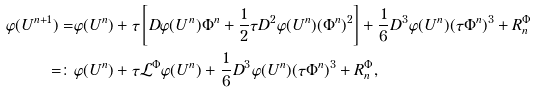Convert formula to latex. <formula><loc_0><loc_0><loc_500><loc_500>\varphi ( U ^ { n + 1 } ) = & \varphi ( U ^ { n } ) + \tau \left [ D \varphi ( U ^ { n } ) \Phi ^ { n } + \frac { 1 } { 2 } \tau D ^ { 2 } \varphi ( U ^ { n } ) ( \Phi ^ { n } ) ^ { 2 } \right ] + \frac { 1 } { 6 } D ^ { 3 } \varphi ( U ^ { n } ) ( \tau \Phi ^ { n } ) ^ { 3 } + R ^ { \Phi } _ { n } \\ = \colon & \varphi ( U ^ { n } ) + \tau \mathcal { L } ^ { \Phi } \varphi ( U ^ { n } ) + \frac { 1 } { 6 } D ^ { 3 } \varphi ( U ^ { n } ) ( \tau \Phi ^ { n } ) ^ { 3 } + R ^ { \Phi } _ { n } ,</formula> 